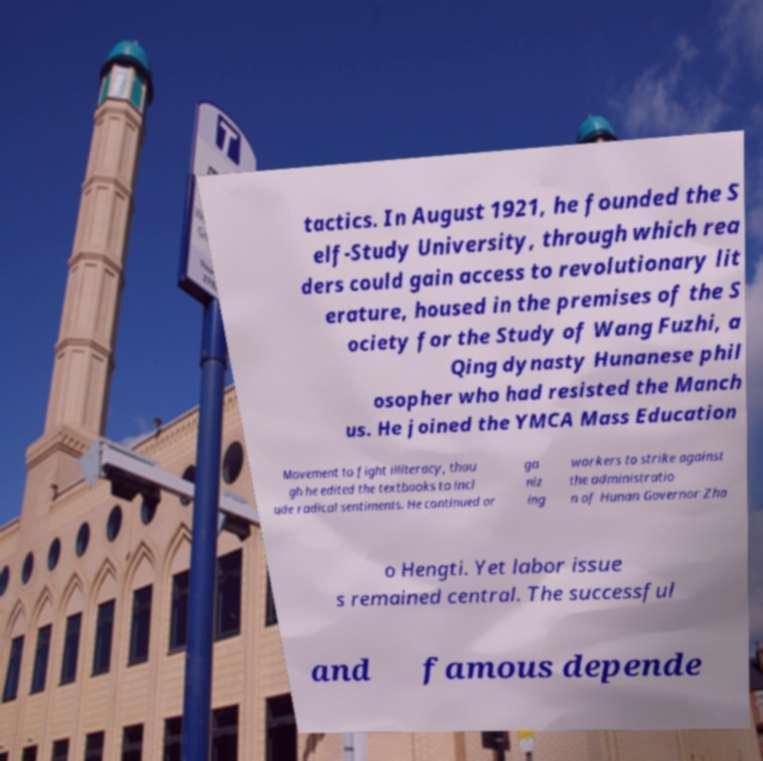Can you accurately transcribe the text from the provided image for me? tactics. In August 1921, he founded the S elf-Study University, through which rea ders could gain access to revolutionary lit erature, housed in the premises of the S ociety for the Study of Wang Fuzhi, a Qing dynasty Hunanese phil osopher who had resisted the Manch us. He joined the YMCA Mass Education Movement to fight illiteracy, thou gh he edited the textbooks to incl ude radical sentiments. He continued or ga niz ing workers to strike against the administratio n of Hunan Governor Zha o Hengti. Yet labor issue s remained central. The successful and famous depende 